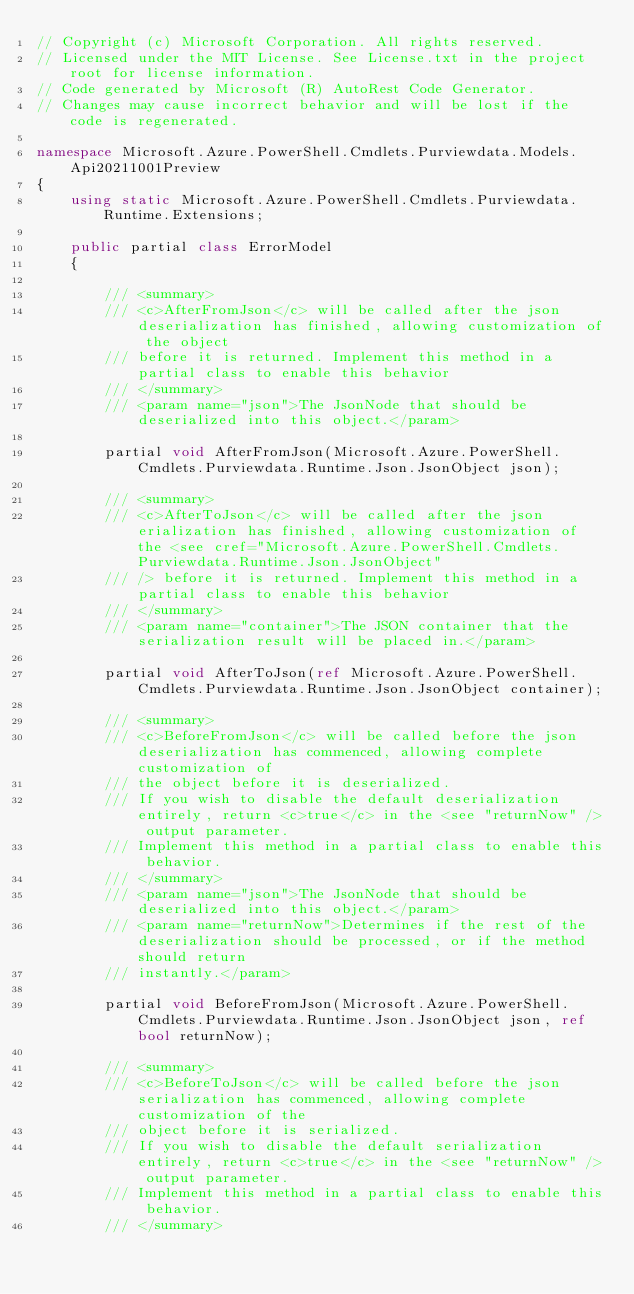Convert code to text. <code><loc_0><loc_0><loc_500><loc_500><_C#_>// Copyright (c) Microsoft Corporation. All rights reserved.
// Licensed under the MIT License. See License.txt in the project root for license information.
// Code generated by Microsoft (R) AutoRest Code Generator.
// Changes may cause incorrect behavior and will be lost if the code is regenerated.

namespace Microsoft.Azure.PowerShell.Cmdlets.Purviewdata.Models.Api20211001Preview
{
    using static Microsoft.Azure.PowerShell.Cmdlets.Purviewdata.Runtime.Extensions;

    public partial class ErrorModel
    {

        /// <summary>
        /// <c>AfterFromJson</c> will be called after the json deserialization has finished, allowing customization of the object
        /// before it is returned. Implement this method in a partial class to enable this behavior
        /// </summary>
        /// <param name="json">The JsonNode that should be deserialized into this object.</param>

        partial void AfterFromJson(Microsoft.Azure.PowerShell.Cmdlets.Purviewdata.Runtime.Json.JsonObject json);

        /// <summary>
        /// <c>AfterToJson</c> will be called after the json erialization has finished, allowing customization of the <see cref="Microsoft.Azure.PowerShell.Cmdlets.Purviewdata.Runtime.Json.JsonObject"
        /// /> before it is returned. Implement this method in a partial class to enable this behavior
        /// </summary>
        /// <param name="container">The JSON container that the serialization result will be placed in.</param>

        partial void AfterToJson(ref Microsoft.Azure.PowerShell.Cmdlets.Purviewdata.Runtime.Json.JsonObject container);

        /// <summary>
        /// <c>BeforeFromJson</c> will be called before the json deserialization has commenced, allowing complete customization of
        /// the object before it is deserialized.
        /// If you wish to disable the default deserialization entirely, return <c>true</c> in the <see "returnNow" /> output parameter.
        /// Implement this method in a partial class to enable this behavior.
        /// </summary>
        /// <param name="json">The JsonNode that should be deserialized into this object.</param>
        /// <param name="returnNow">Determines if the rest of the deserialization should be processed, or if the method should return
        /// instantly.</param>

        partial void BeforeFromJson(Microsoft.Azure.PowerShell.Cmdlets.Purviewdata.Runtime.Json.JsonObject json, ref bool returnNow);

        /// <summary>
        /// <c>BeforeToJson</c> will be called before the json serialization has commenced, allowing complete customization of the
        /// object before it is serialized.
        /// If you wish to disable the default serialization entirely, return <c>true</c> in the <see "returnNow" /> output parameter.
        /// Implement this method in a partial class to enable this behavior.
        /// </summary></code> 